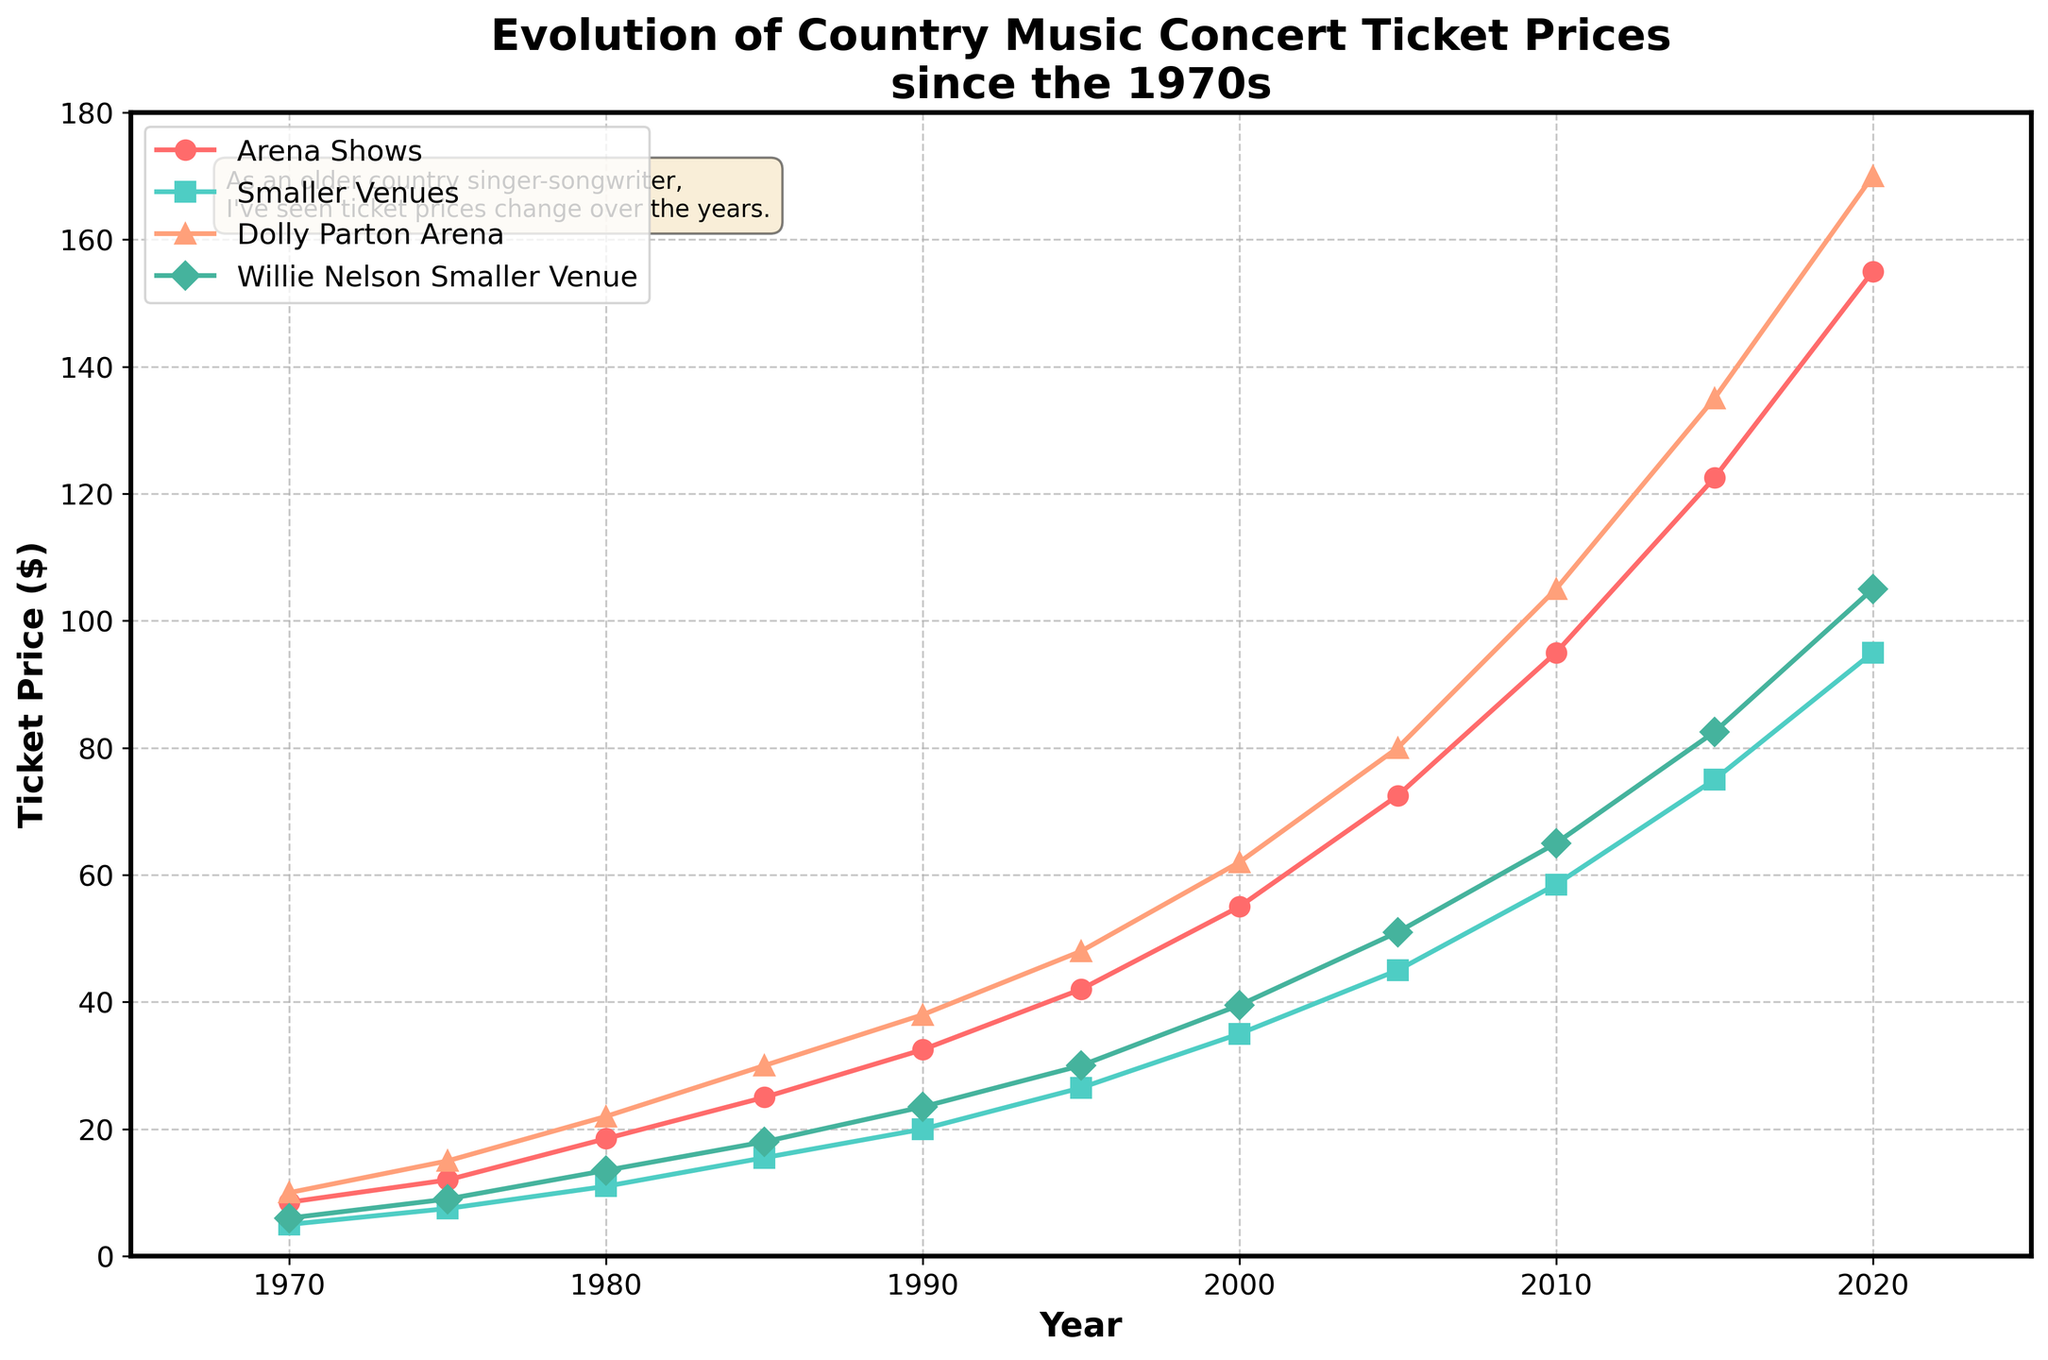What trend do you notice in the ticket prices for Arena Shows since the 1970s? The ticket prices for Arena Shows have been steadily increasing over the years. Starting from $8.50 in 1970, they reached $155.00 by 2020, reflecting a consistent upward trend.
Answer: Steadily increasing How did the ticket prices for Smaller Venues in 2020 compare to those for Arena Shows? In 2020, the ticket price for Smaller Venues was $95.00, while for Arena Shows, it was $155.00. The Arena Show tickets were more expensive by $60.00.
Answer: Arena Shows were $60.00 more expensive What years saw the biggest increase in ticket prices for Arena Shows? By examining the trend, we see significant increases in the periods between 2000-2005 and 2005-2010, where prices increased from $55.00 to $72.50 and from $72.50 to $95.00, respectively.
Answer: 2000-2010 What's the difference in ticket prices between Dolly Parton Arena and Willie Nelson Smaller Venue in 2015? In 2015, Dolly Parton Arena tickets were $135.00, and Willie Nelson Smaller Venue tickets were $82.50. The difference is $135.00 - $82.50 = $52.50.
Answer: $52.50 Compare the rate of increase in ticket prices for Arena Shows and Smaller Venues from 1970 to 2020. From 1970 to 2020, Arena Show prices increased from $8.50 to $155.00, a difference of $146.50. Smaller Venue prices increased from $5.00 to $95.00, a difference of $90.00. Thus, Arena Shows saw a higher rate of increase by $56.50.
Answer: Arena Shows had a higher increase by $56.50 How do Dolly Parton Arena ticket prices in 1980 compare with Arena Show ticket prices the same year? In 1980, Dolly Parton Arena tickets were priced at $22.00, while Arena Show tickets were priced at $18.50. Dolly Parton Arena tickets were more expensive by $3.50.
Answer: $3.50 more expensive What is the average ticket price for Smaller Venues in the dataset? Summing up the prices for Smaller Venues from 1970 to 2020: $5.00 + $7.50 + $11.00 + $15.50 + $20.00 + $26.50 + $35.00 + $45.00 + $58.50 + $75.00 + $95.00 = $394.00. Dividing by the 11 data points: 394 / 11 = $35.82.
Answer: $35.82 Between 2010 and 2015, which had a greater percentage increase in ticket prices: Arena Shows or Smaller Venues? For Arena Shows, the increase from 2010 to 2015 was from $95.00 to $122.50. The percentage increase is (122.50 - 95.00) / 95.00 × 100 = 29%. For Smaller Venues, the increase from $58.50 to $75.00 is (75.00 - 58.50) / 58.50 × 100 = 28.2%. Arena Shows had a slightly greater percentage increase.
Answer: Arena Shows (29%) In what year did Willie Nelson Smaller Venue ticket prices first exceed the general Smaller Venues average for that year? Calculating yearly comparisons: 
- 1970: $6.00 < $5.00
- 1975: $9.00 > $7.50
Therefore, the first year Willie Nelson Smaller Venue ticket prices exceeded the Smaller Venues average was 1975.
Answer: 1975 